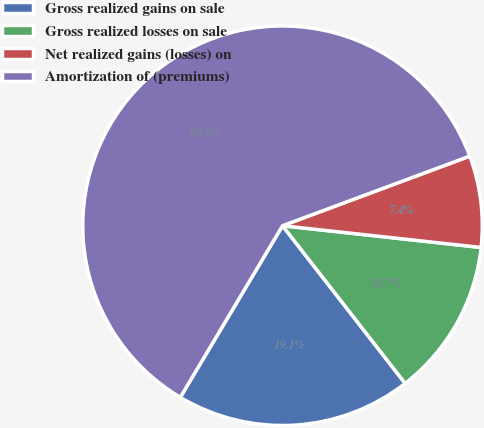Convert chart to OTSL. <chart><loc_0><loc_0><loc_500><loc_500><pie_chart><fcel>Gross realized gains on sale<fcel>Gross realized losses on sale<fcel>Net realized gains (losses) on<fcel>Amortization of (premiums)<nl><fcel>19.07%<fcel>12.74%<fcel>7.4%<fcel>60.78%<nl></chart> 